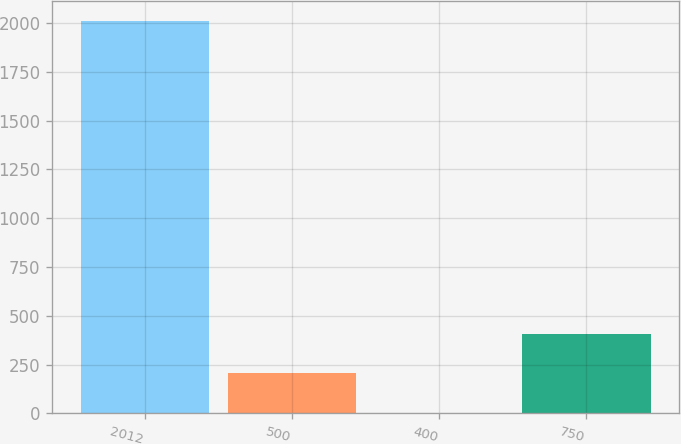Convert chart to OTSL. <chart><loc_0><loc_0><loc_500><loc_500><bar_chart><fcel>2012<fcel>500<fcel>400<fcel>750<nl><fcel>2010<fcel>204.6<fcel>4<fcel>405.2<nl></chart> 